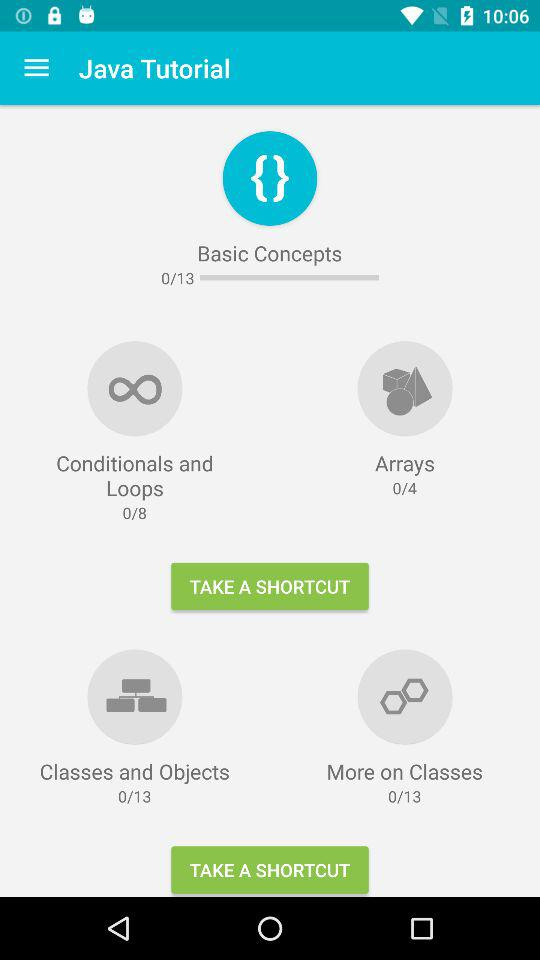What are the topics available? The available topics are "Conditionals and Loops", "Arrays", "Classes and Objects" and "More on Classes". 